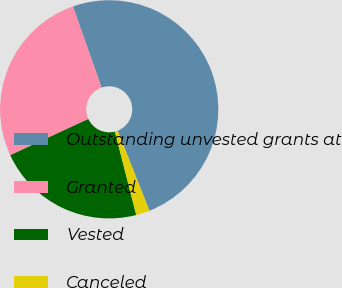<chart> <loc_0><loc_0><loc_500><loc_500><pie_chart><fcel>Outstanding unvested grants at<fcel>Granted<fcel>Vested<fcel>Canceled<nl><fcel>49.4%<fcel>26.51%<fcel>22.07%<fcel>2.02%<nl></chart> 